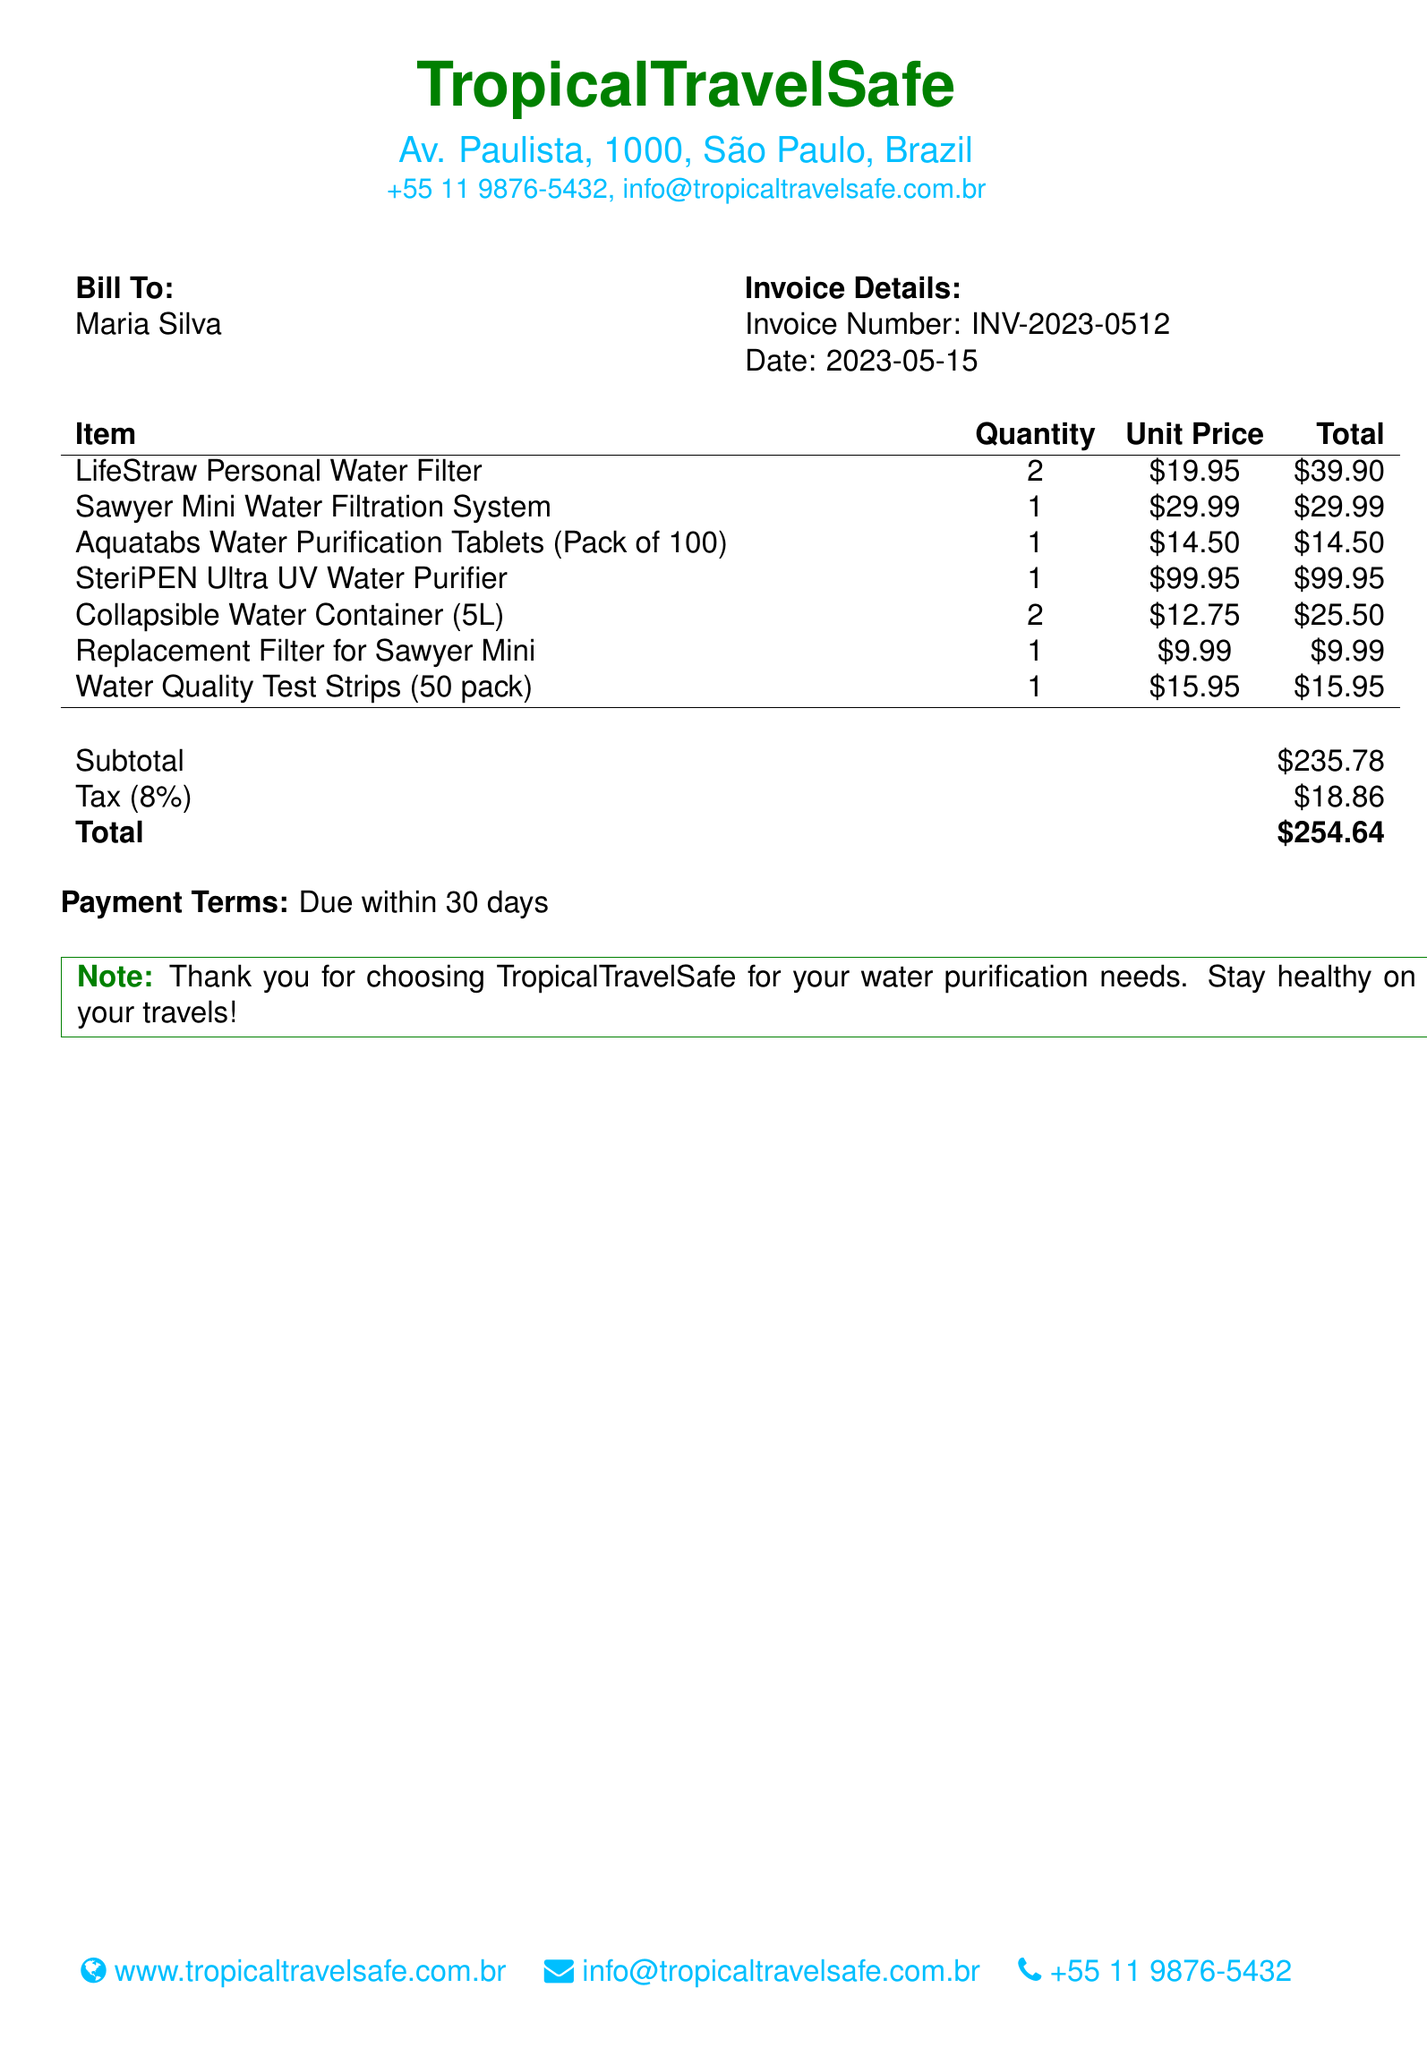What is the invoice number? The invoice number is listed in the document under "Invoice Details."
Answer: INV-2023-0512 What is the date of the invoice? The date is specified along with the invoice number in the document.
Answer: 2023-05-15 Who is the bill addressed to? The name of the person the bill is addressed to is mentioned at the beginning.
Answer: Maria Silva How many LifeStraw Personal Water Filters were purchased? The quantity of LifeStraw Personal Water Filters is detailed in the itemized list.
Answer: 2 What is the total amount due? The total amount due is presented at the bottom of the invoice summary.
Answer: $254.64 What is the tax rate applied? The tax rate is stated in the subtotal section of the document.
Answer: 8% What is the unit price of the SteriPEN Ultra UV Water Purifier? The unit price of this item is listed in the itemized section of the bill.
Answer: $99.95 What is the subtotal of the items before tax? The subtotal is given in the summary before tax is added.
Answer: $235.78 What is the payment term mentioned in the document? The payment terms are clearly stated in the relevant section of the bill.
Answer: Due within 30 days 